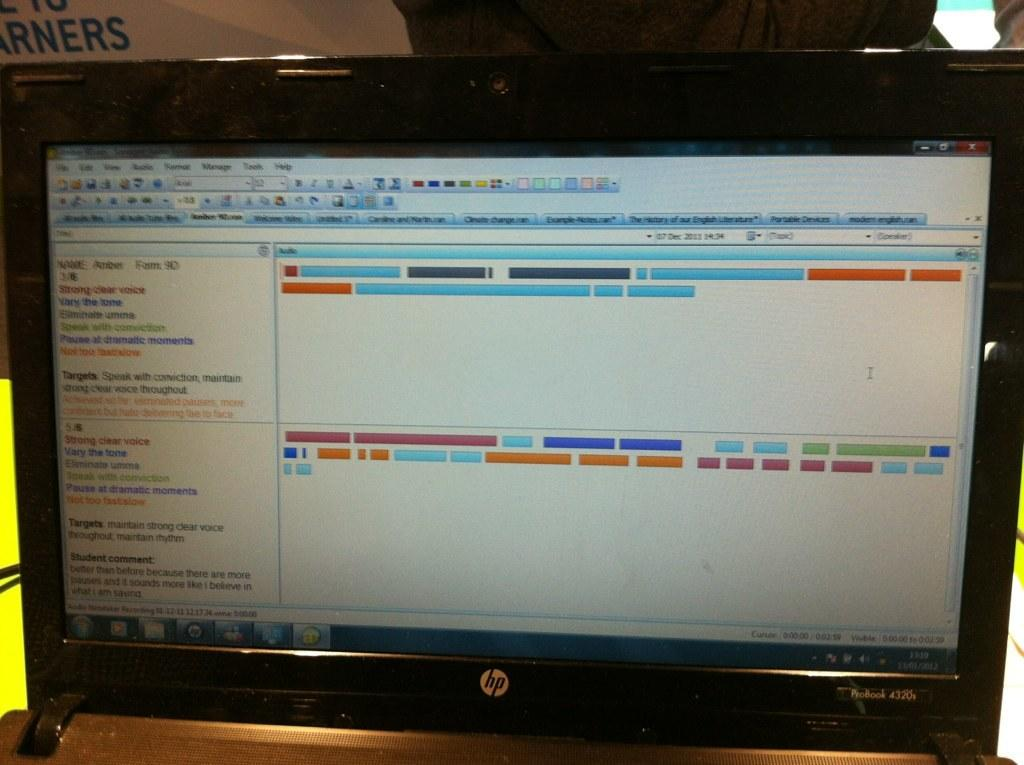Provide a one-sentence caption for the provided image. HP laptop screen that says "Strong Clear Voice" on the left. 